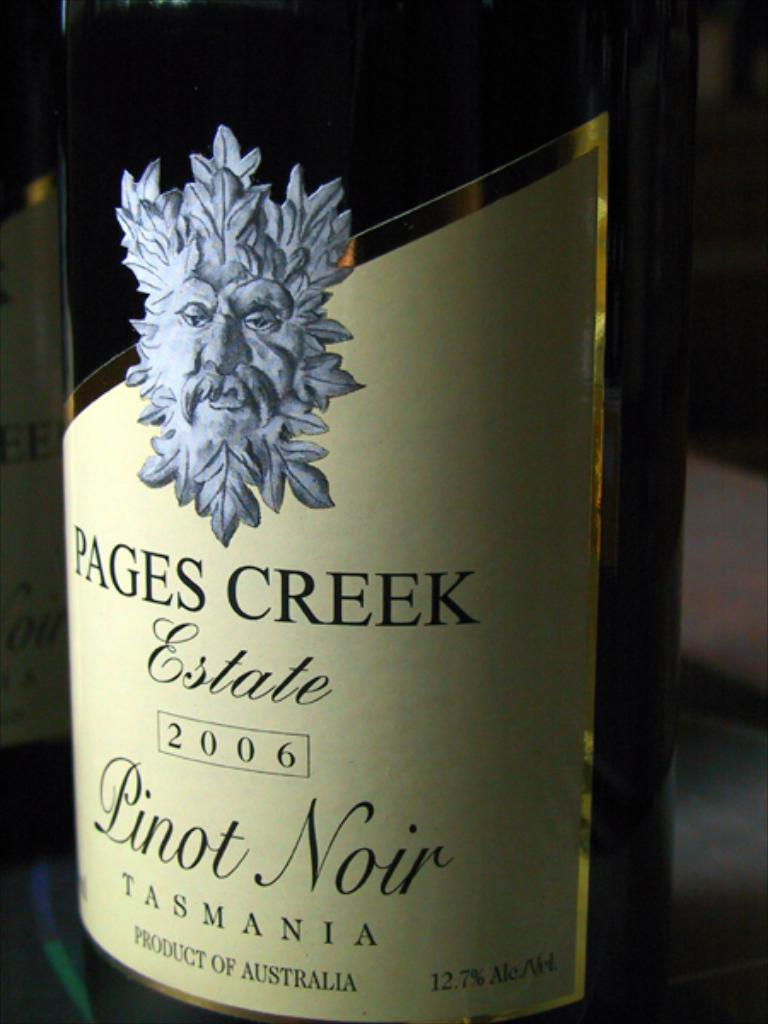<image>
Describe the image concisely. The bottle of Pinot Noir is a product of Australia. 